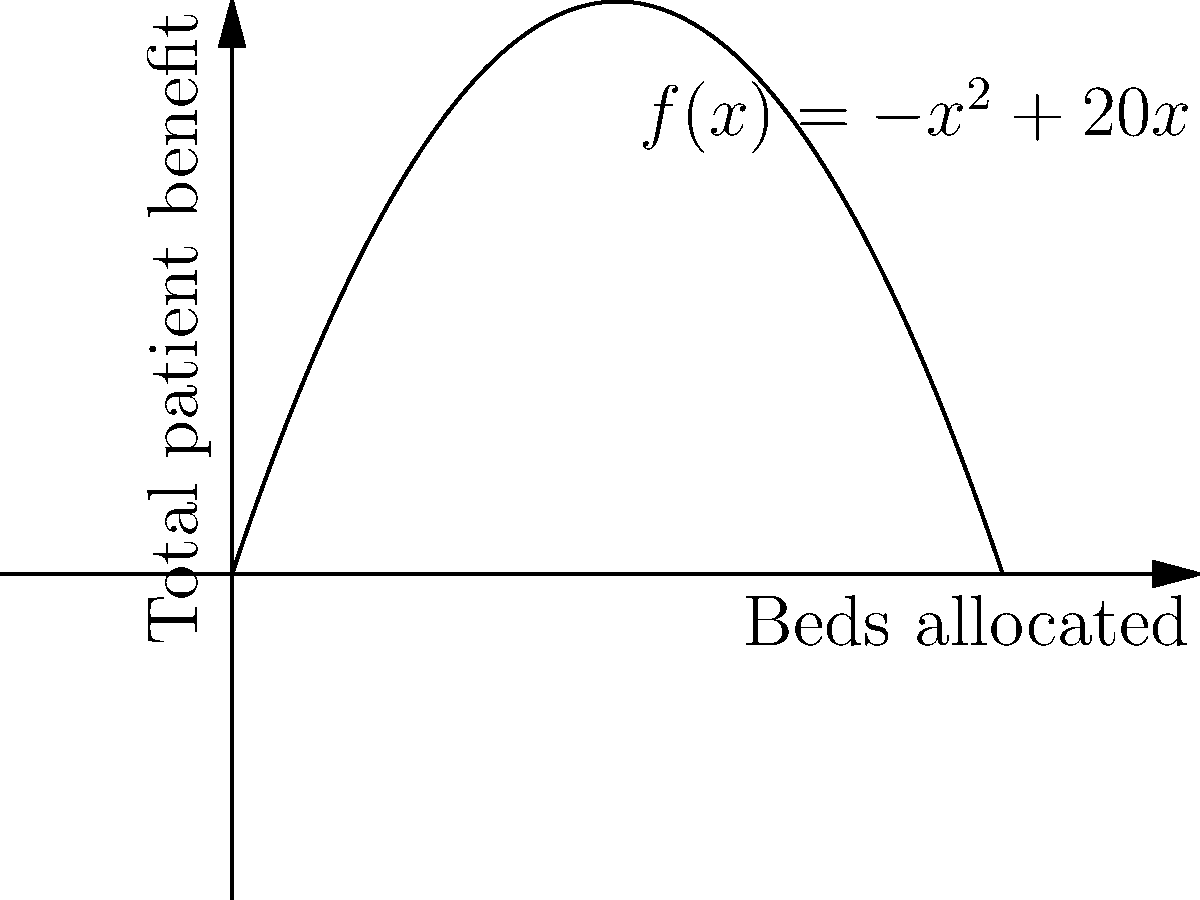A psychiatric facility is allocating resources for patient care. The total benefit to patients, measured in arbitrary units, can be modeled by the function $f(x) = -x^2 + 20x$, where $x$ is the number of beds allocated. What is the optimal number of beds to allocate to maximize patient benefit, and what is the maximum benefit achieved? To find the optimal number of beds and the maximum benefit:

1) The function $f(x) = -x^2 + 20x$ is a quadratic function, which forms a parabola.

2) To find the maximum of a quadratic function, we need to find its vertex.

3) For a quadratic function in the form $f(x) = ax^2 + bx + c$, the x-coordinate of the vertex is given by $x = -\frac{b}{2a}$.

4) In our case, $a = -1$, $b = 20$, and $c = 0$.

5) Therefore, the optimal number of beds is:
   $x = -\frac{20}{2(-1)} = \frac{20}{2} = 10$ beds

6) To find the maximum benefit, we substitute $x = 10$ into the original function:
   $f(10) = -(10)^2 + 20(10) = -100 + 200 = 100$ units

Thus, the optimal number of beds is 10, and the maximum benefit is 100 units.
Answer: 10 beds; 100 units 